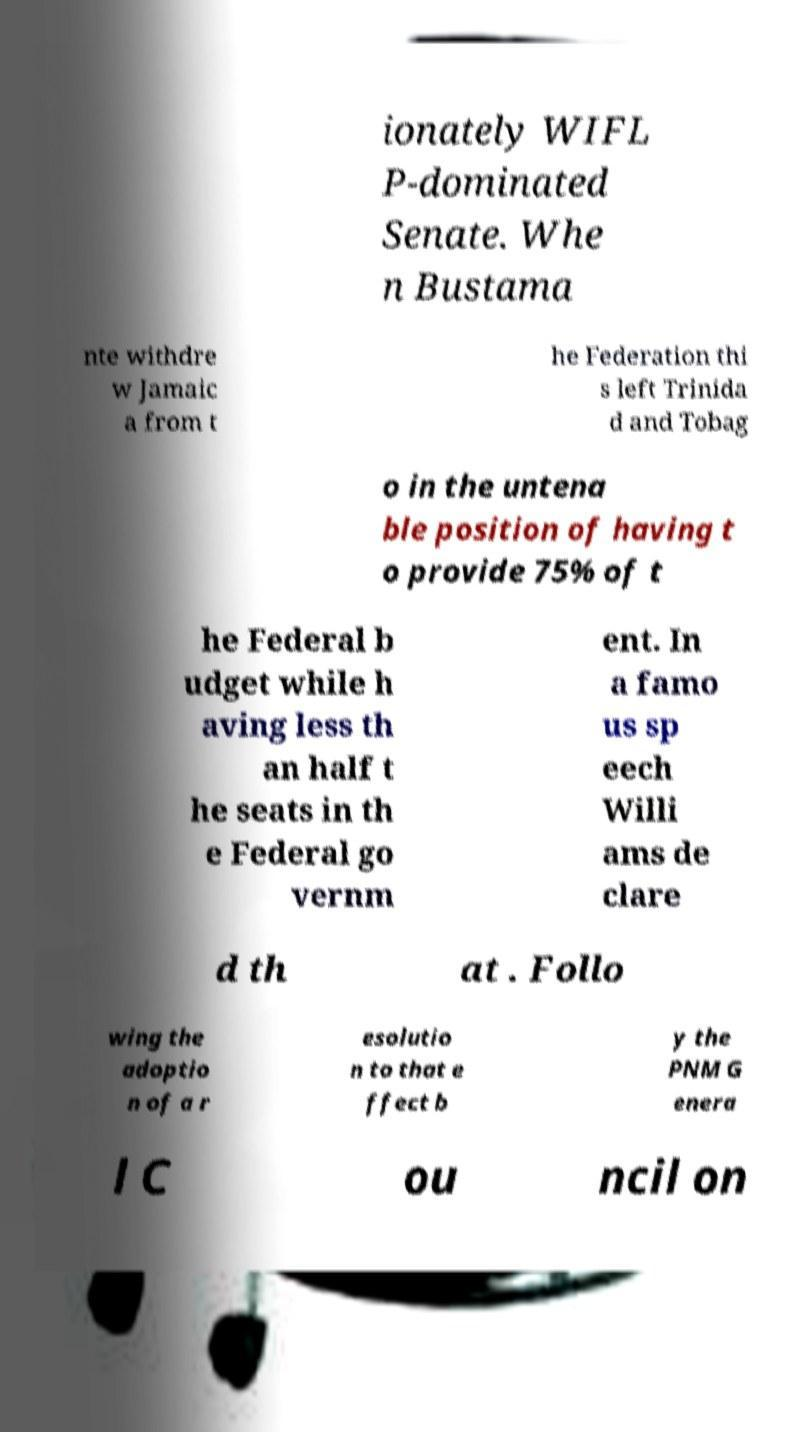Please identify and transcribe the text found in this image. ionately WIFL P-dominated Senate. Whe n Bustama nte withdre w Jamaic a from t he Federation thi s left Trinida d and Tobag o in the untena ble position of having t o provide 75% of t he Federal b udget while h aving less th an half t he seats in th e Federal go vernm ent. In a famo us sp eech Willi ams de clare d th at . Follo wing the adoptio n of a r esolutio n to that e ffect b y the PNM G enera l C ou ncil on 